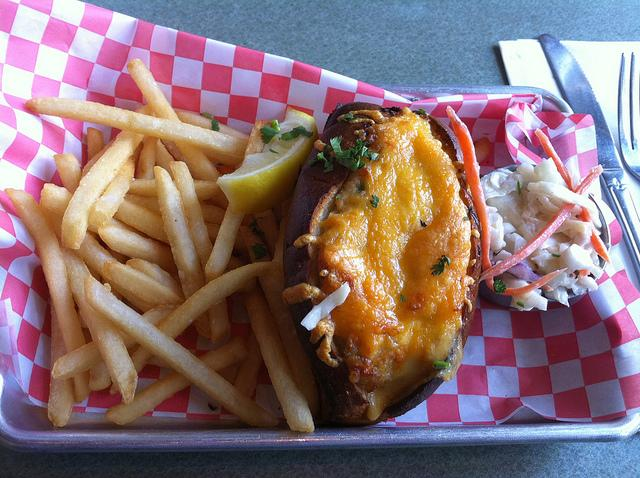Which food item on the plate is highest in fat? Please explain your reasoning. cheese. That food is high in saturated fat. dairy is usually fattening. 